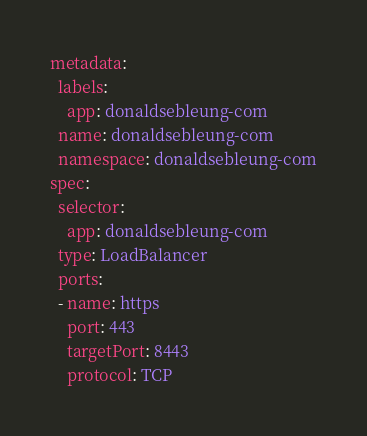<code> <loc_0><loc_0><loc_500><loc_500><_YAML_>metadata:
  labels:
    app: donaldsebleung-com
  name: donaldsebleung-com
  namespace: donaldsebleung-com
spec:
  selector:    
    app: donaldsebleung-com
  type: LoadBalancer
  ports:  
  - name: https
    port: 443
    targetPort: 8443
    protocol: TCP
</code> 